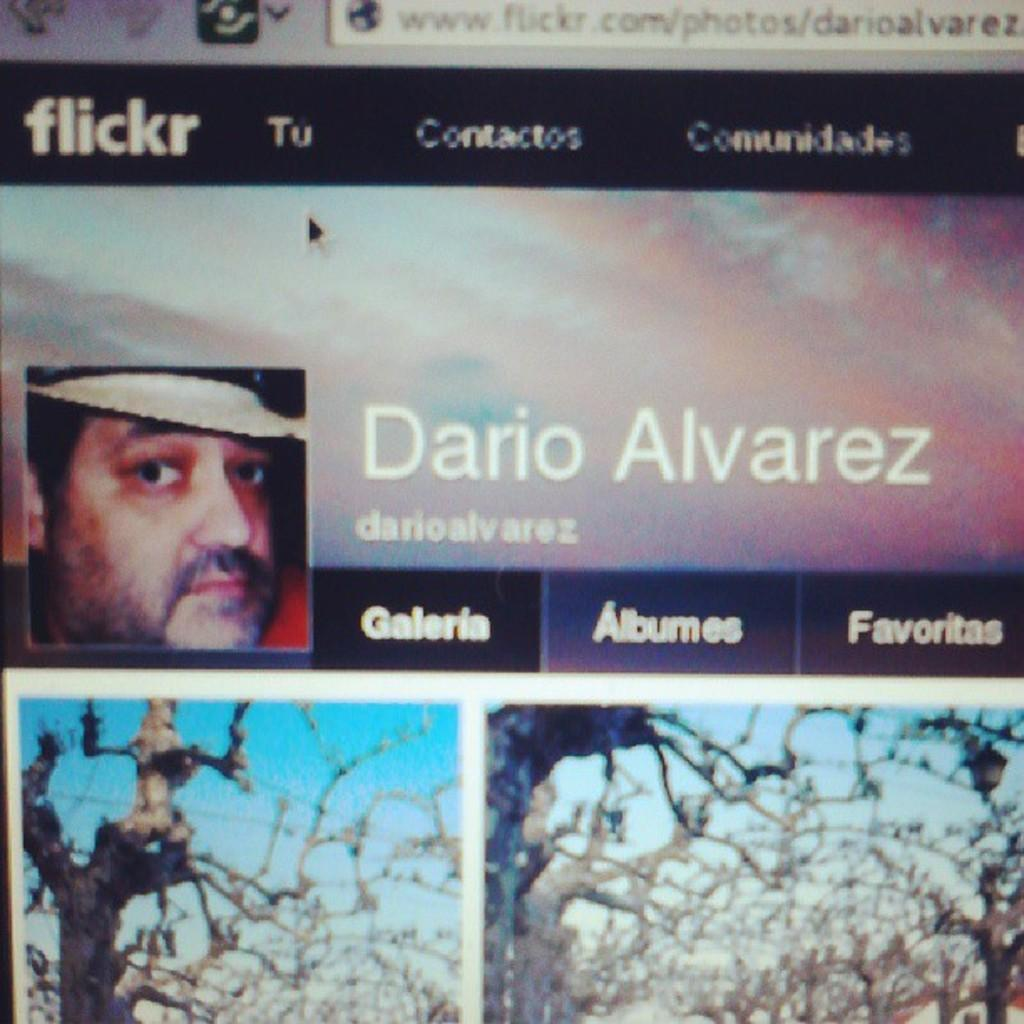What is the main object in the image? There is a computer screen in the image. What can be seen on the computer screen? The computer screen displays pictures. Can you describe the person's face visible in the image? There is a person's face visible in the image. What type of natural scenery is present in the image? There are trees and the sky visible in the image. What type of comb is being used to style the person's hair in the image? There is no comb visible in the image, and the person's hair is not being styled. What amusement park can be seen in the background of the image? There is no amusement park present in the image; it features a computer screen displaying pictures, a person's face, trees, and the sky. 